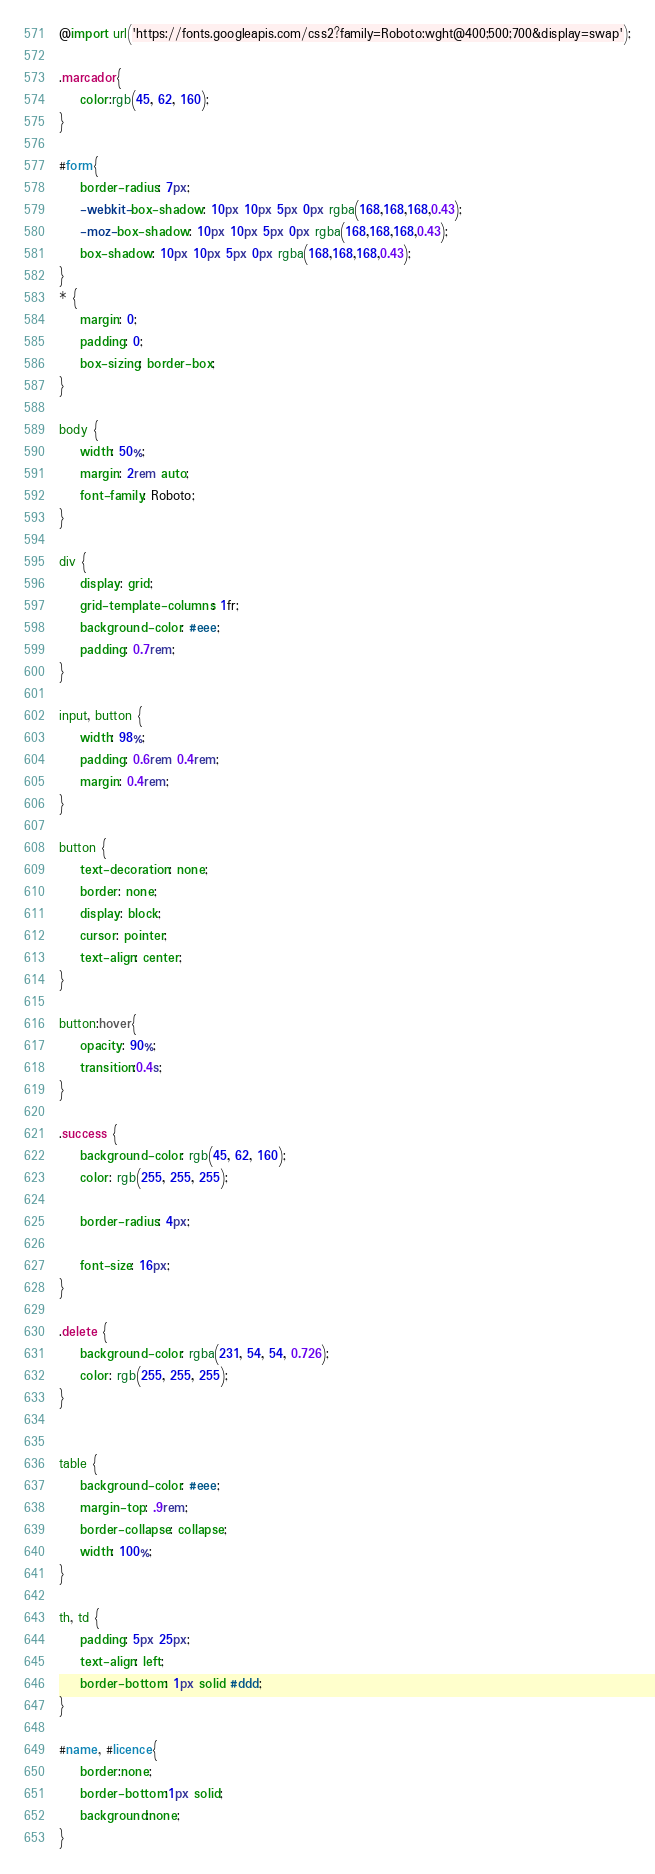Convert code to text. <code><loc_0><loc_0><loc_500><loc_500><_CSS_>@import url('https://fonts.googleapis.com/css2?family=Roboto:wght@400;500;700&display=swap');

.marcador{
    color:rgb(45, 62, 160);
}

#form{
    border-radius: 7px;
    -webkit-box-shadow: 10px 10px 5px 0px rgba(168,168,168,0.43);
    -moz-box-shadow: 10px 10px 5px 0px rgba(168,168,168,0.43);
    box-shadow: 10px 10px 5px 0px rgba(168,168,168,0.43);
}
* {
    margin: 0;
    padding: 0;
    box-sizing: border-box;
}

body {
    width: 50%;
    margin: 2rem auto;
    font-family: Roboto;
}

div {
    display: grid;
    grid-template-columns: 1fr;
    background-color: #eee;
    padding: 0.7rem;
}

input, button {
    width: 98%;
    padding: 0.6rem 0.4rem;
    margin: 0.4rem;
}

button {
    text-decoration: none;
    border: none;
    display: block;
    cursor: pointer;
    text-align: center;
}

button:hover{
    opacity: 90%;
    transition:0.4s;
}

.success {
    background-color: rgb(45, 62, 160);
    color: rgb(255, 255, 255);

    border-radius: 4px;

    font-size: 16px;
}

.delete {
    background-color: rgba(231, 54, 54, 0.726);
    color: rgb(255, 255, 255);
}


table {
    background-color: #eee;
    margin-top: .9rem;
    border-collapse: collapse;
    width: 100%;
}

th, td {
    padding: 5px 25px;
    text-align: left;
    border-bottom: 1px solid #ddd;
}

#name, #licence{
    border:none;
    border-bottom:1px solid;
    background:none;
}</code> 